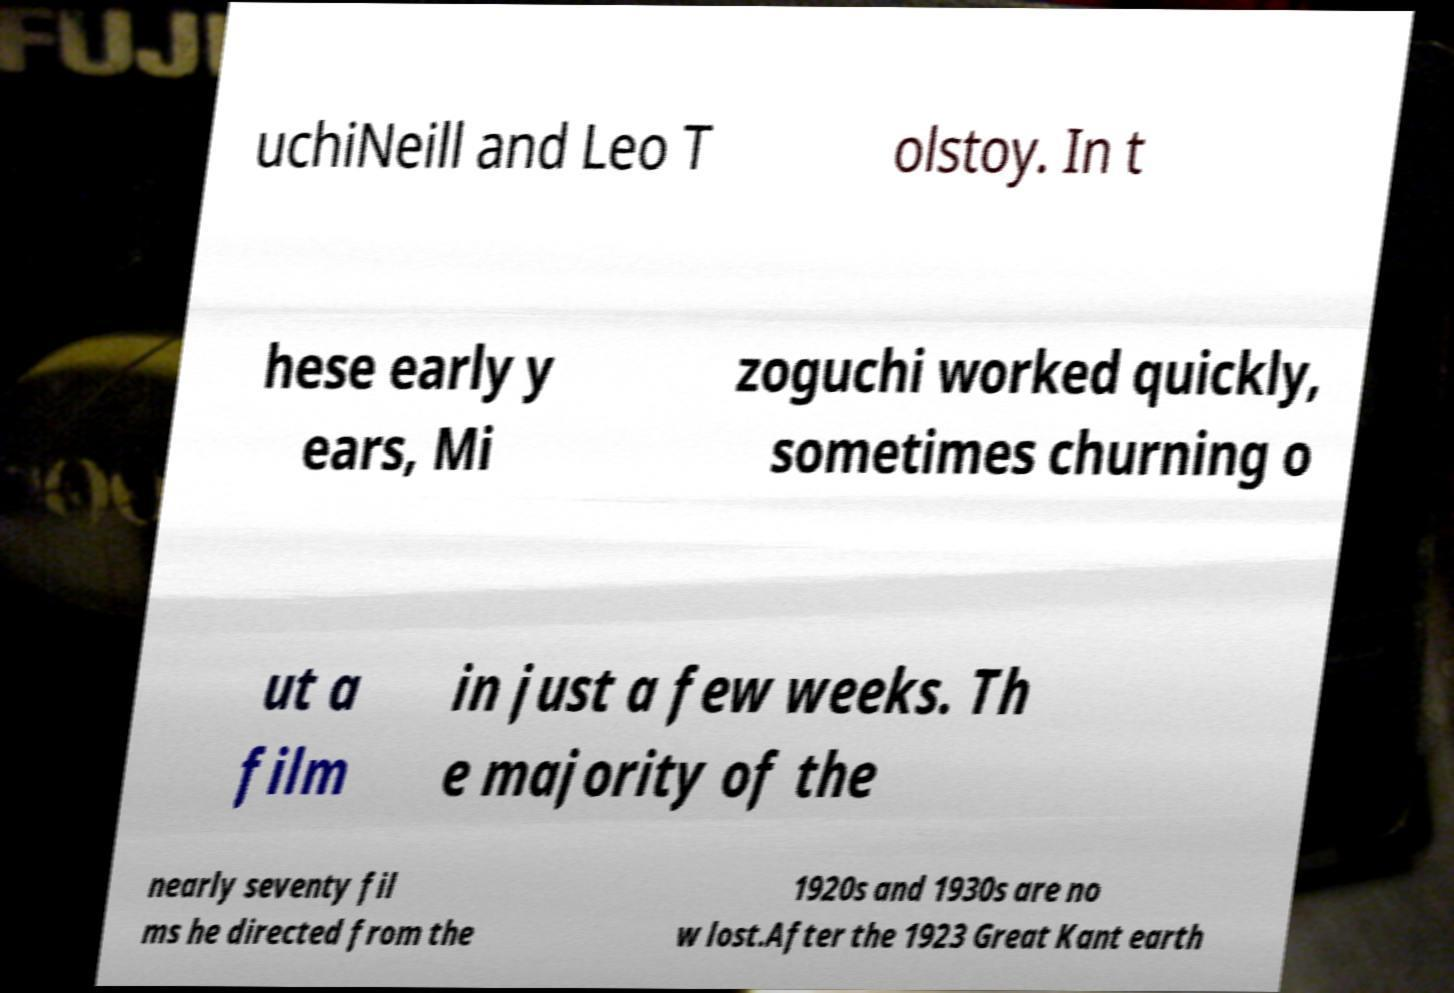I need the written content from this picture converted into text. Can you do that? uchiNeill and Leo T olstoy. In t hese early y ears, Mi zoguchi worked quickly, sometimes churning o ut a film in just a few weeks. Th e majority of the nearly seventy fil ms he directed from the 1920s and 1930s are no w lost.After the 1923 Great Kant earth 